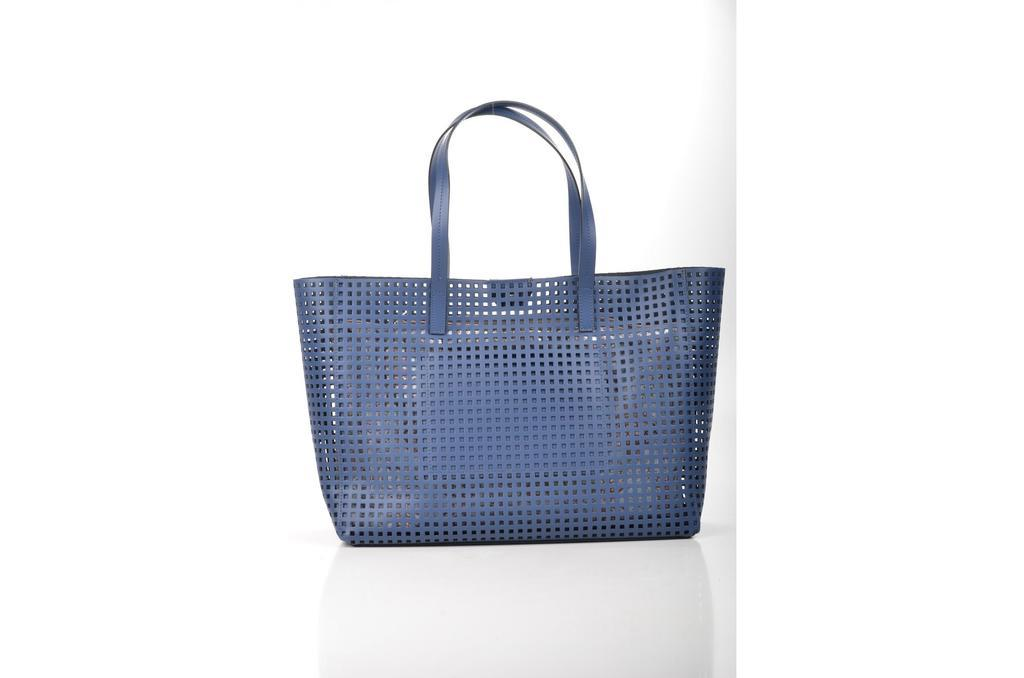What color is the handbag in the image? The handbag in the image is blue. How many stitches can be seen on the handbag in the image? There is no information about stitches on the handbag in the provided facts, so it cannot be determined from the image. 